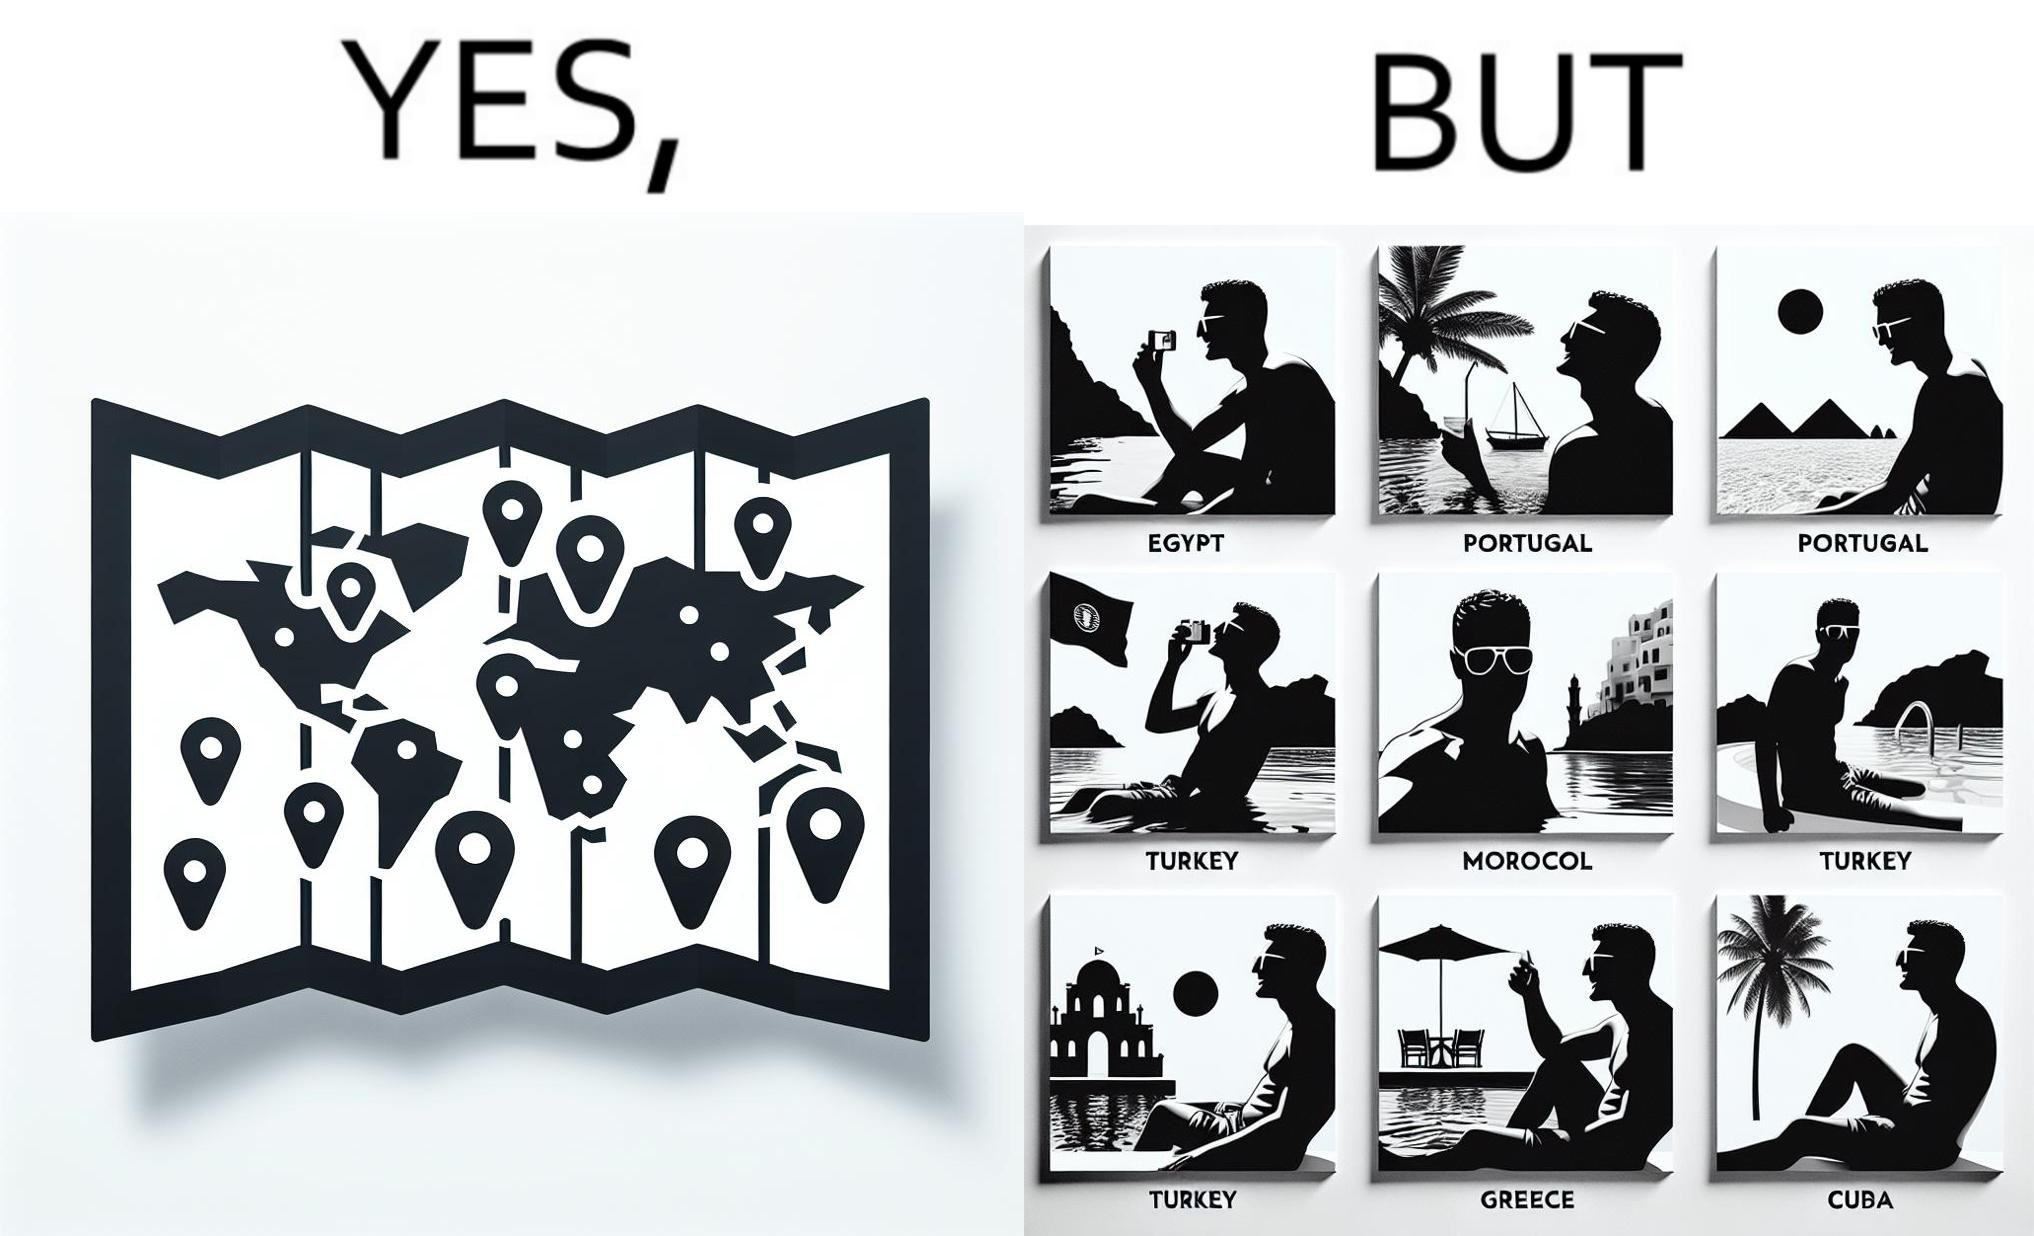Does this image contain satire or humor? Yes, this image is satirical. 